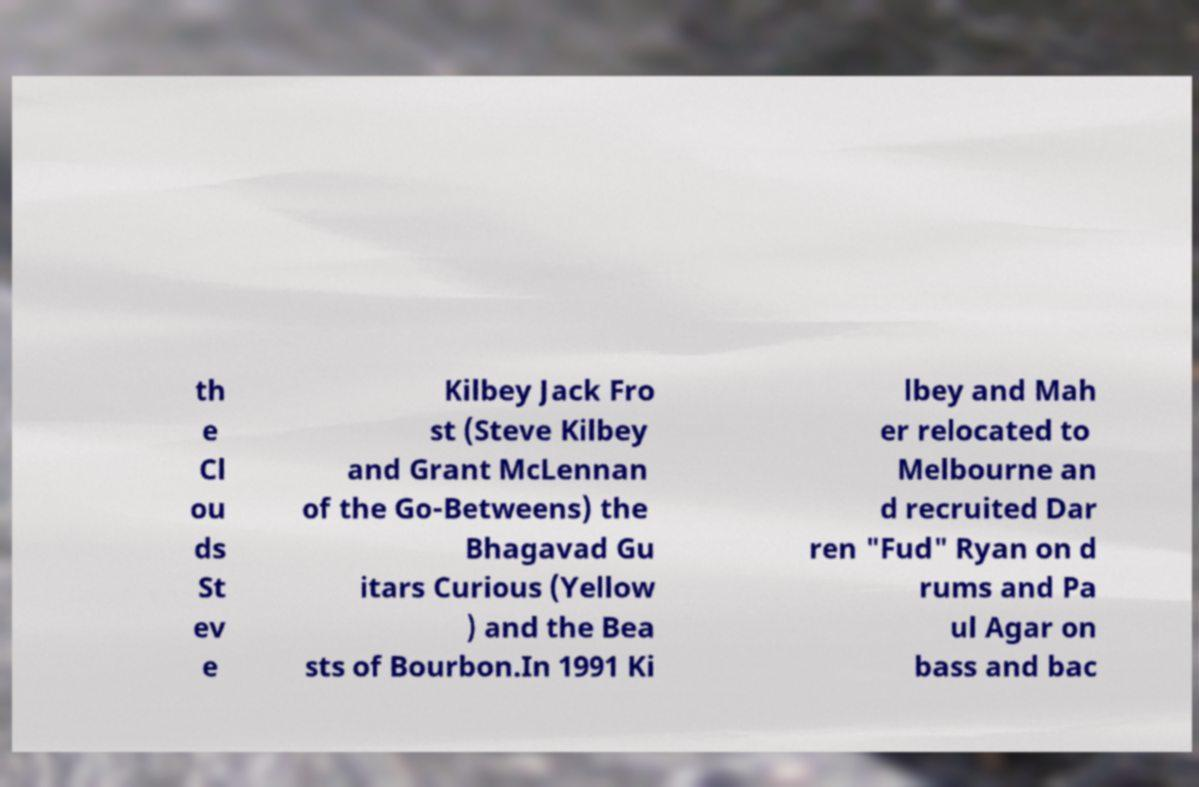Can you accurately transcribe the text from the provided image for me? th e Cl ou ds St ev e Kilbey Jack Fro st (Steve Kilbey and Grant McLennan of the Go-Betweens) the Bhagavad Gu itars Curious (Yellow ) and the Bea sts of Bourbon.In 1991 Ki lbey and Mah er relocated to Melbourne an d recruited Dar ren "Fud" Ryan on d rums and Pa ul Agar on bass and bac 